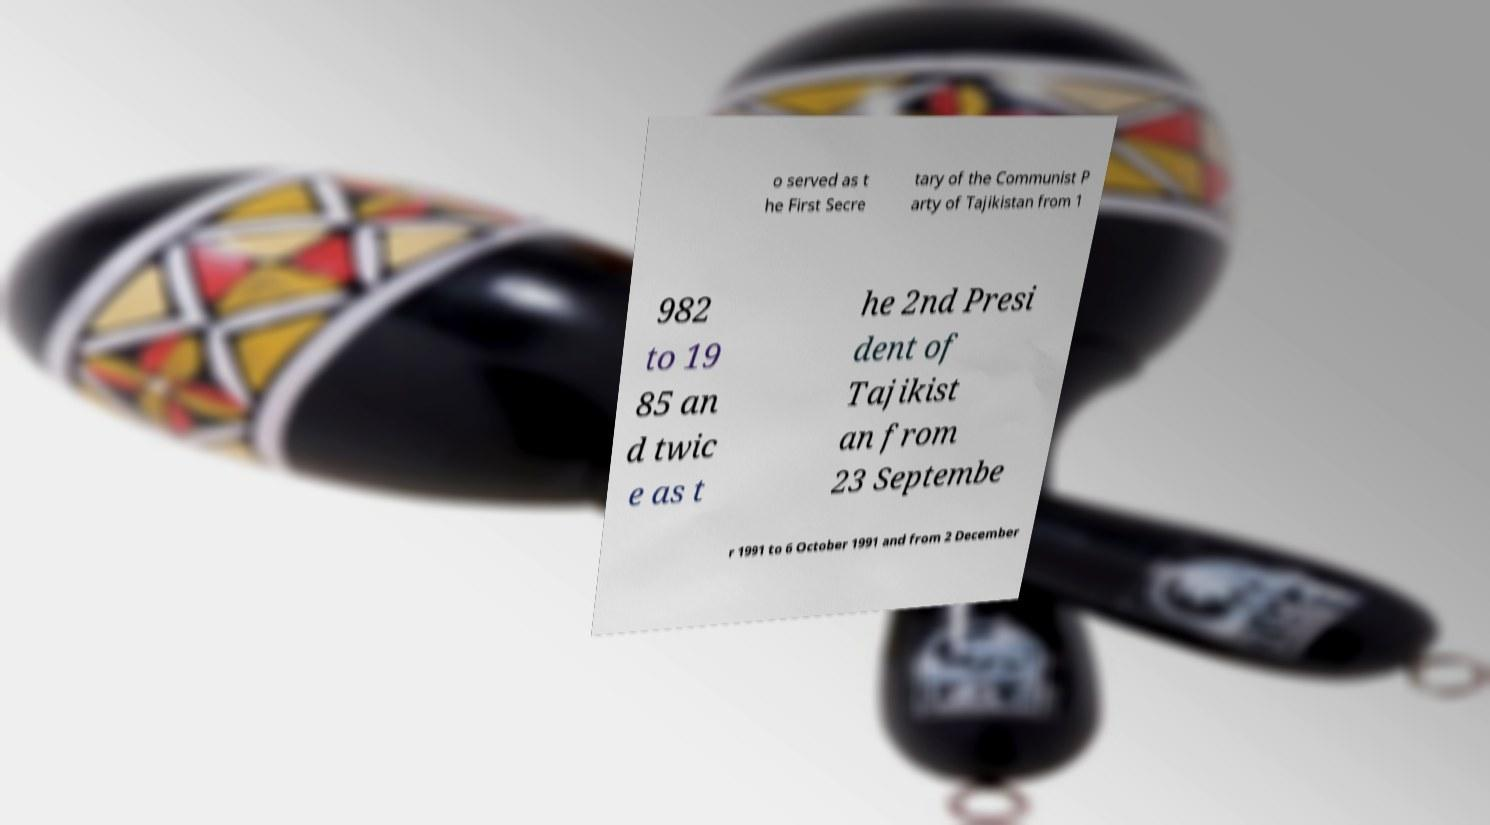Could you assist in decoding the text presented in this image and type it out clearly? o served as t he First Secre tary of the Communist P arty of Tajikistan from 1 982 to 19 85 an d twic e as t he 2nd Presi dent of Tajikist an from 23 Septembe r 1991 to 6 October 1991 and from 2 December 